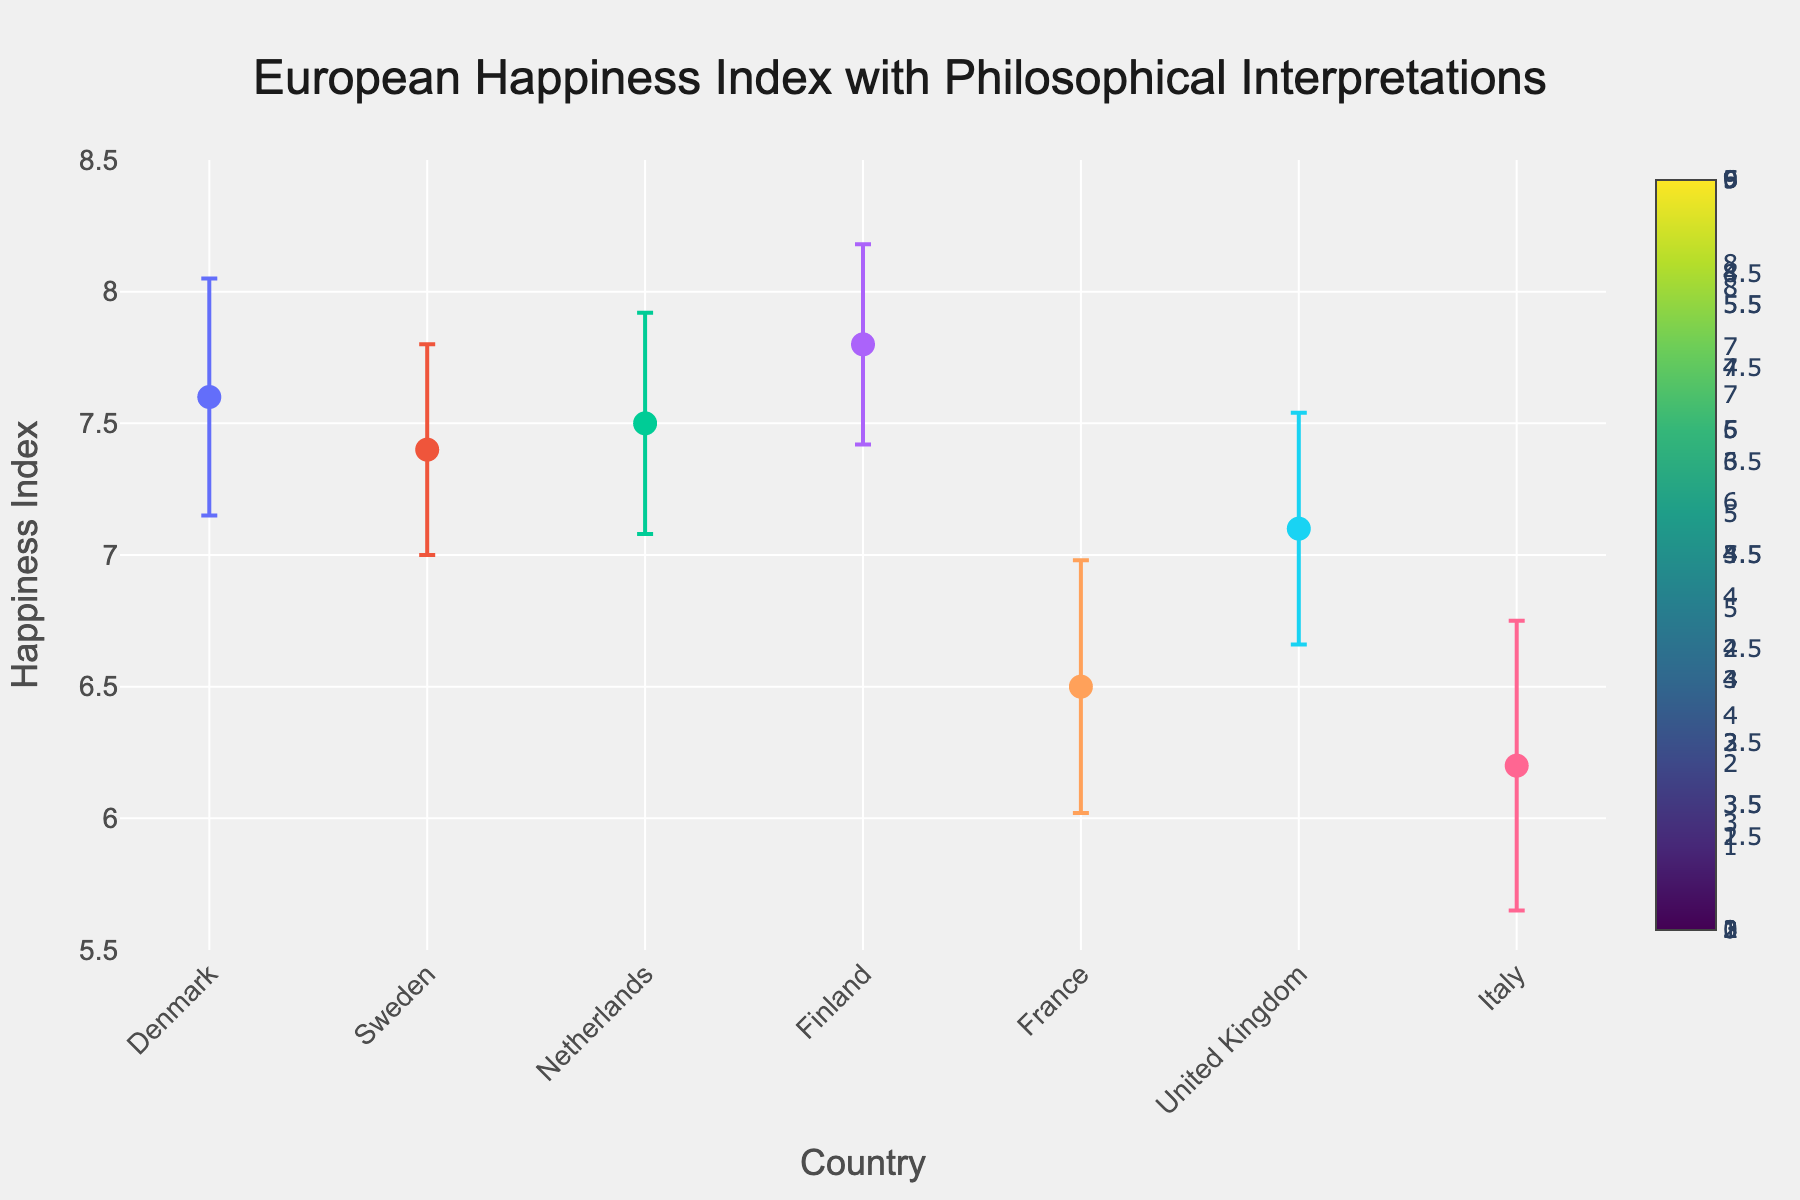What's the highest Happiness Index value shown on the plot? First, identify the y-axis which represents the Happiness Index. Then, look at the highest data point marked on the plot.
Answer: 7.8 Which country has the lowest Happiness Index value? Identify all the points on the graph and their corresponding countries. The lowest value among them is for the country with the Happiness Index of 6.2.
Answer: Italy What is the average Happiness Index value for the countries shown? Add the Happiness Index values for all countries: 7.6 (Denmark) + 7.4 (Sweden) + 7.5 (Netherlands) + 7.8 (Finland) + 6.5 (France) + 7.1 (United Kingdom) + 6.2 (Italy). Then, divide by the number of countries (7). The calculation is (7.6 + 7.4 + 7.5 + 7.8 + 6.5 + 7.1 + 6.2) / 7 = 50.1 / 7.
Answer: 7.16 How do Finland and France compare in terms of the Standard Deviation of their Happiness Index? Look at the error bars of both countries. Finland has a standard deviation of 0.38 and France has a standard deviation of 0.48. Compare these values.
Answer: Finland's standard deviation is lower than France's What does the error bar represent in this figure? The error bar indicates the standard deviation of the Happiness Index for each country, conveying the variability and uncertainty in the data.
Answer: Standard deviation Which country has the smallest standard deviation in its Happiness Index? Identify the shortest error bar among the countries. The country with the smallest standard deviation is the one with the smallest error bar. Finland's error bar is the smallest among them.
Answer: Finland How does the Happiness Index of Italy compare to the expected well-being interpretation provided? Observe Italy's data point, its Happiness Index (6.2), and compare it with the Philosophical Interpretation provided in the text. Italy has a lower Happiness Index, reflecting the stated challenges despite strong family ties.
Answer: Italy has a low Happiness Index If you were to categorize the Happiness Index into "High" (above 7.0) and "Low" (7.0 or below), which countries fall into the "Low" category? First, define the threshold. Then, check each data point to see if its Happiness Index is 7.0 or below. France and Italy have Happiness Indexes below or equal to 7.0.
Answer: France, Italy What cultural element is associated with Finland's high Happiness Index? Refer to Finland's data point and the "Philosophical Interpretation" text associated with it, which mentions "sisu" and resilience as contributing elements.
Answer: 'Sisu' and resilience Which country’s Happiness Index is closest to the average Happiness Index of the listed countries? First, calculate the average Happiness Index as done before (7.16). Compare each country's index to find the nearest value. The UK has a Happiness Index of 7.1, closest to the average.
Answer: United Kingdom 